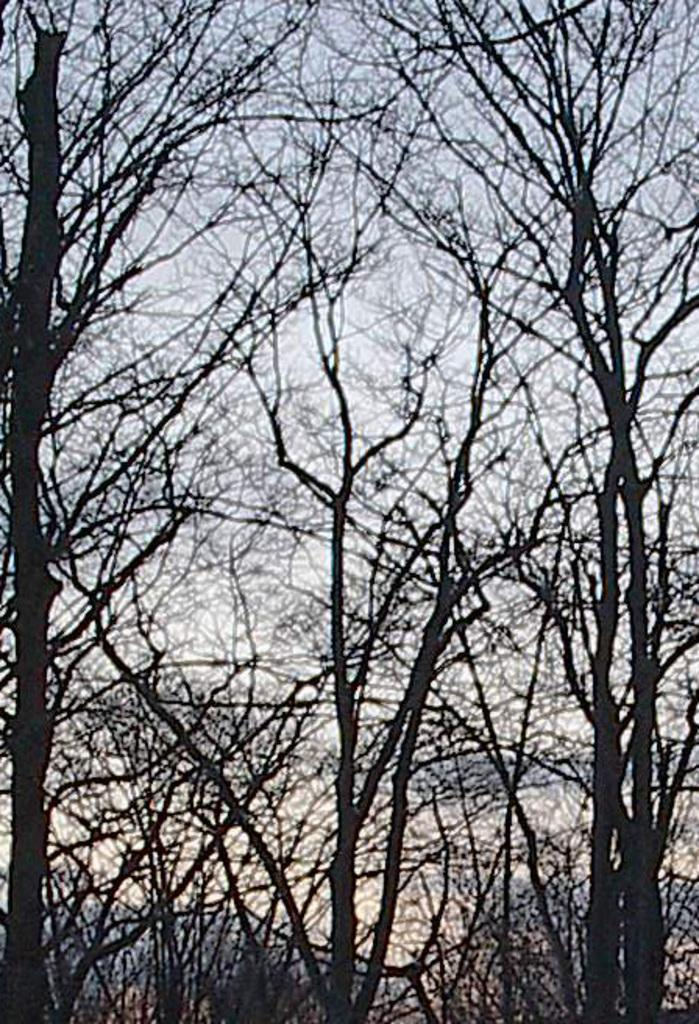What type of vegetation can be seen in the image? There are trees in the image. What part of the natural environment is visible in the image? The sky is visible in the image. How many clovers can be seen growing among the trees in the image? There is no mention of clovers in the image, so it is not possible to determine how many might be present. 